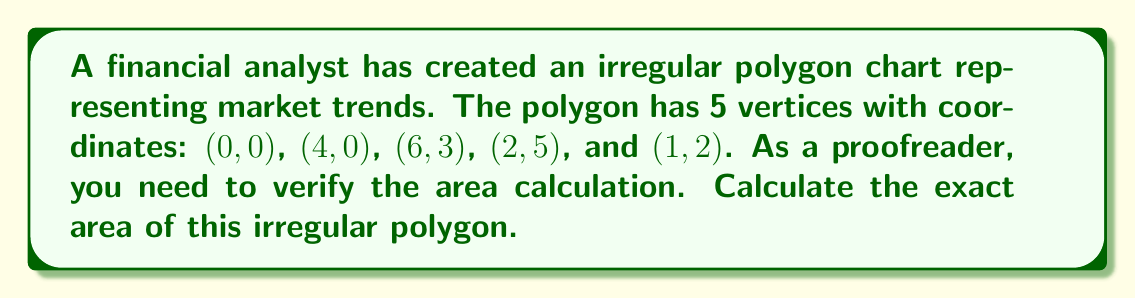Could you help me with this problem? To calculate the area of an irregular polygon, we can use the Shoelace formula (also known as the surveyor's formula). The steps are as follows:

1) List the coordinates in order (clockwise or counterclockwise):
   $(x_1,y_1) = (0,0)$
   $(x_2,y_2) = (4,0)$
   $(x_3,y_3) = (6,3)$
   $(x_4,y_4) = (2,5)$
   $(x_5,y_5) = (1,2)$

2) Apply the Shoelace formula:

   $$A = \frac{1}{2}|(x_1y_2 + x_2y_3 + x_3y_4 + x_4y_5 + x_5y_1) - (y_1x_2 + y_2x_3 + y_3x_4 + y_4x_5 + y_5x_1)|$$

3) Substitute the values:

   $$A = \frac{1}{2}|(0 \cdot 0 + 4 \cdot 3 + 6 \cdot 5 + 2 \cdot 2 + 1 \cdot 0) - (0 \cdot 4 + 0 \cdot 6 + 3 \cdot 2 + 5 \cdot 1 + 2 \cdot 0)|$$

4) Simplify:

   $$A = \frac{1}{2}|(0 + 12 + 30 + 4 + 0) - (0 + 0 + 6 + 5 + 0)|$$
   $$A = \frac{1}{2}|46 - 11|$$
   $$A = \frac{1}{2} \cdot 35$$
   $$A = 17.5$$

Therefore, the exact area of the irregular polygon is 17.5 square units.
Answer: 17.5 square units 